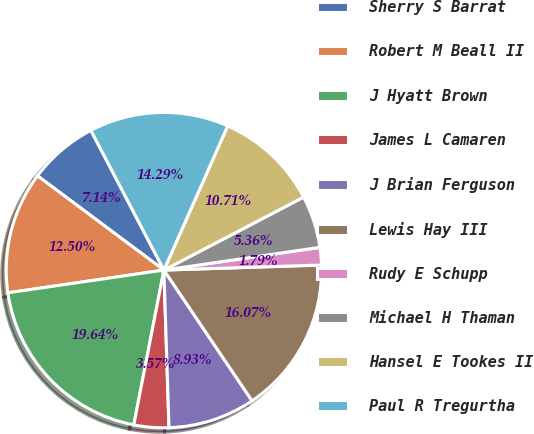<chart> <loc_0><loc_0><loc_500><loc_500><pie_chart><fcel>Sherry S Barrat<fcel>Robert M Beall II<fcel>J Hyatt Brown<fcel>James L Camaren<fcel>J Brian Ferguson<fcel>Lewis Hay III<fcel>Rudy E Schupp<fcel>Michael H Thaman<fcel>Hansel E Tookes II<fcel>Paul R Tregurtha<nl><fcel>7.14%<fcel>12.5%<fcel>19.64%<fcel>3.57%<fcel>8.93%<fcel>16.07%<fcel>1.79%<fcel>5.36%<fcel>10.71%<fcel>14.29%<nl></chart> 